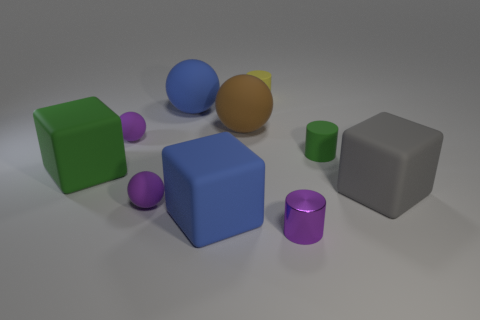How many other objects are there of the same size as the metallic thing?
Offer a terse response. 4. What number of large objects are either yellow cylinders or blocks?
Offer a very short reply. 3. What is the color of the small metal cylinder?
Offer a terse response. Purple. What shape is the purple rubber object behind the green rubber object right of the large brown matte thing?
Your answer should be compact. Sphere. Is there a tiny sphere made of the same material as the big gray block?
Keep it short and to the point. Yes. Do the rubber cube that is to the right of the purple metallic cylinder and the tiny purple metal thing have the same size?
Keep it short and to the point. No. How many blue objects are small shiny objects or cylinders?
Provide a succinct answer. 0. What material is the tiny cylinder that is on the left side of the tiny metal thing?
Make the answer very short. Rubber. There is a purple rubber sphere behind the large green rubber thing; how many blue rubber spheres are behind it?
Offer a very short reply. 1. What number of small shiny things are the same shape as the large gray rubber object?
Make the answer very short. 0. 